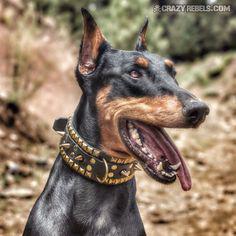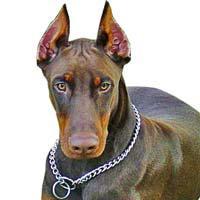The first image is the image on the left, the second image is the image on the right. Assess this claim about the two images: "At least one doberman has its tongue out.". Correct or not? Answer yes or no. Yes. The first image is the image on the left, the second image is the image on the right. Analyze the images presented: Is the assertion "Each image shows at least one doberman wearing a collar, and one image shows a camera-gazing close-mouthed dog in a chain collar, while the other image includes a rightward-gazing dog with its pink tongue hanging out." valid? Answer yes or no. Yes. 